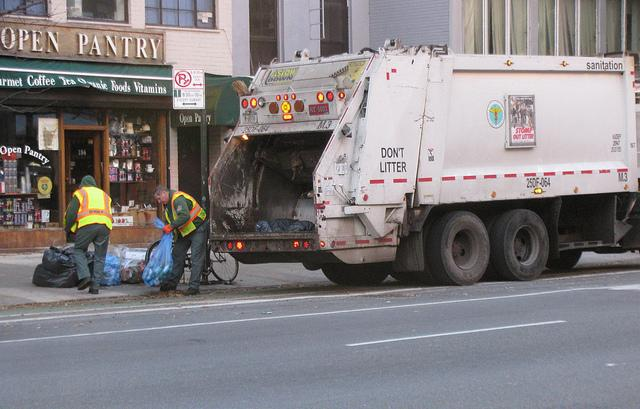Why are the men wearing yellow vests? safety 